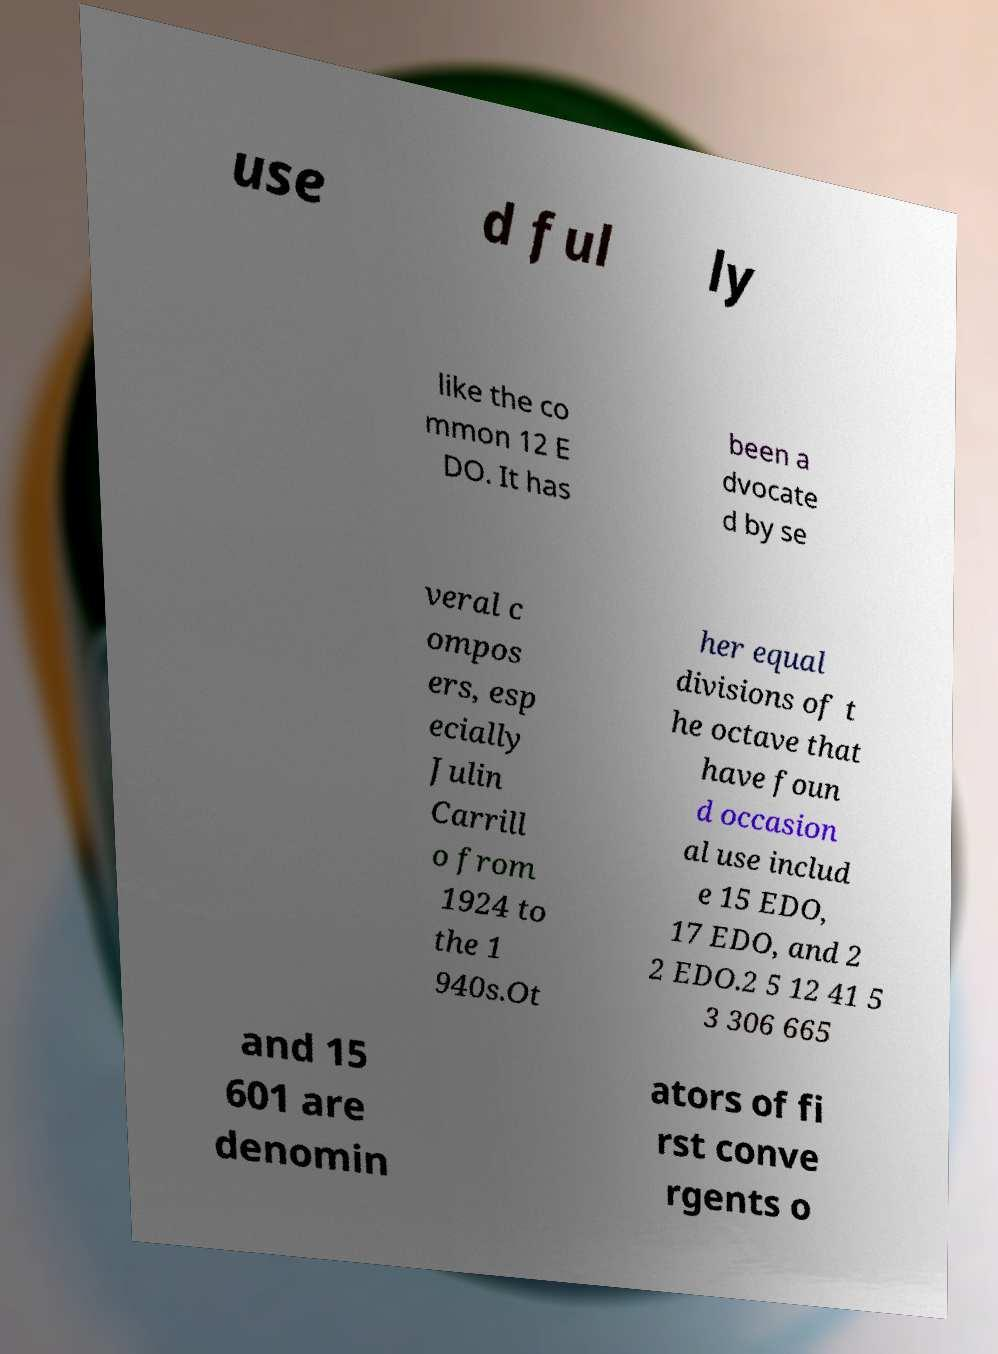There's text embedded in this image that I need extracted. Can you transcribe it verbatim? use d ful ly like the co mmon 12 E DO. It has been a dvocate d by se veral c ompos ers, esp ecially Julin Carrill o from 1924 to the 1 940s.Ot her equal divisions of t he octave that have foun d occasion al use includ e 15 EDO, 17 EDO, and 2 2 EDO.2 5 12 41 5 3 306 665 and 15 601 are denomin ators of fi rst conve rgents o 